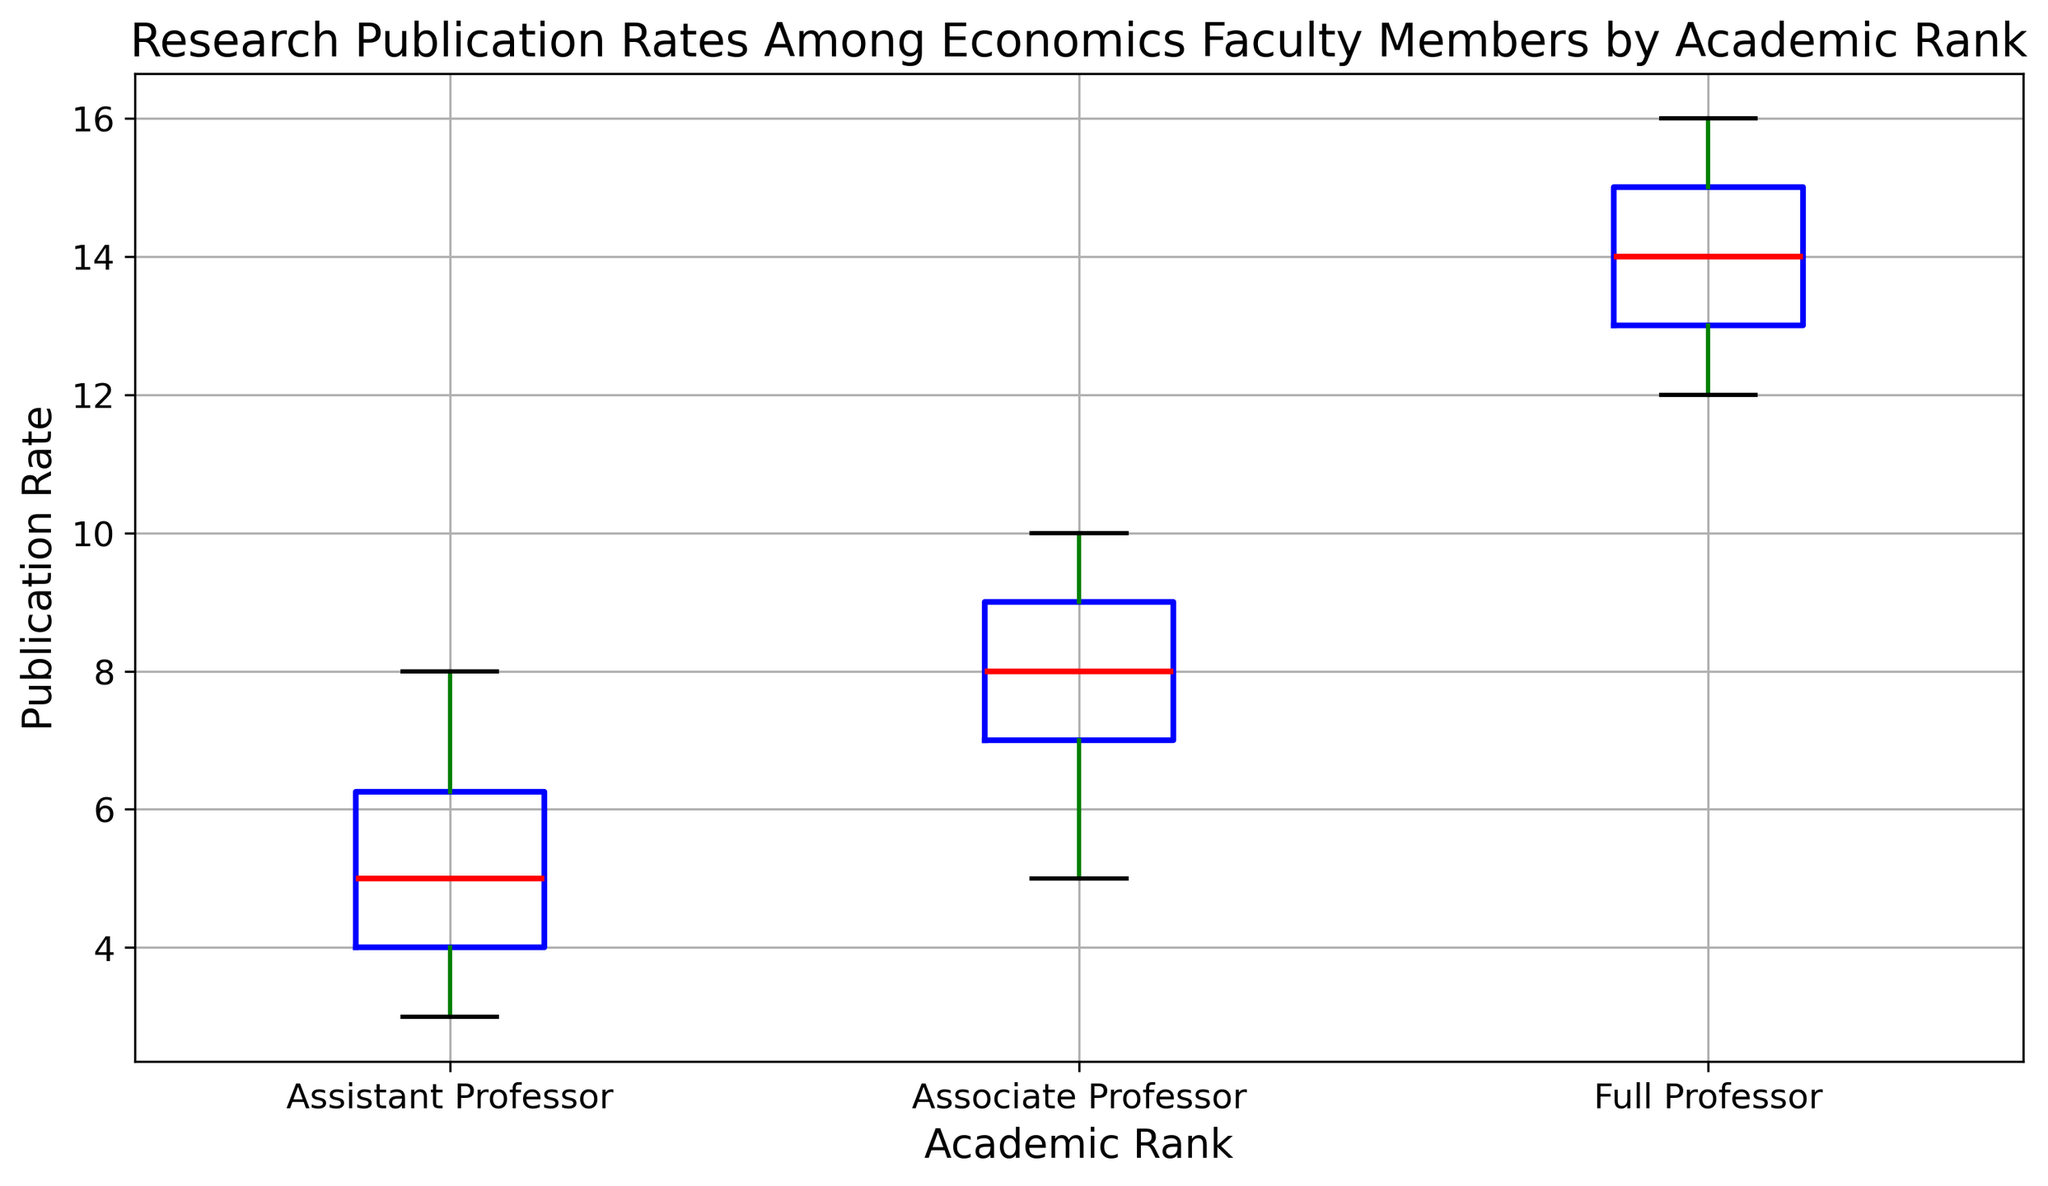What's the median publication rate for Associate Professors? Identify the box plot for Associate Professors and locate the horizontal line within the box (the median line). The median publication rate for Associate Professors is at this median line.
Answer: 8 Is the median publication rate higher for Full Professors or Associate Professors? Compare the median lines in the box plots for Full Professors and Associate Professors. The median line for Full Professors is higher than that for Associate Professors.
Answer: Full Professors Which rank has the widest range of publication rates? The range is determined by the distance between the bottom whisker and the top whisker. The rank with the widest spread between these whiskers has the widest range. Full Professors have the widest range.
Answer: Full Professors What is the interquartile range (IQR) of publication rates for Assistant Professors? The IQR is the difference between the third quartile (top edge of the box) and the first quartile (bottom edge of the box). For Assistant Professors, this is calculated by subtracting the lower quartile value from the upper quartile value.
Answer: 3 (7-4) Compare the maximum publication rates among different ranks. Which rank has the highest maximum publication rate? Look at the highest points (top whiskers) in the box plots across all ranks. Full Professors have the highest maximum publication rate.
Answer: Full Professors Is there any overlap in the publication rates between Associate Professors and Full Professors? Observe the whiskers and boxes of both Associate Professors and Full Professors. If there are common values in their ranges, there is an overlap. The boxes and whiskers of Associate and Full Professors do overlap.
Answer: Yes What is the difference between the medians of Full Professors and Assistant Professors? Locate the median lines for Full Professors and Assistant Professors, and then calculate the difference. The median for Full Professors is 14, and for Assistant Professors, it is 5. The difference is 14 - 5.
Answer: 9 Which rank has the smallest interquartile range (IQR)? Identify the length of the boxes for each rank. The rank with the smallest box length has the smallest IQR. Associate Professors have the smallest IQR.
Answer: Associate Professors What visual characteristics differentiate the whiskers from the boxes in the plot? Notice the color and thickness details: the whiskers are green and thinner, whereas the boxes are blue and thicker.
Answer: Color and thickness 